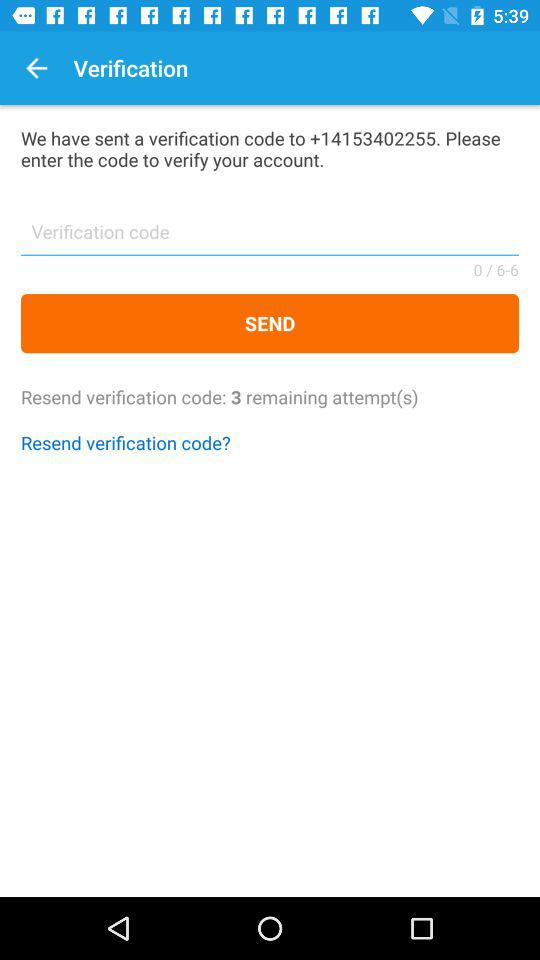What is the verification code?
When the provided information is insufficient, respond with <no answer>. <no answer> 